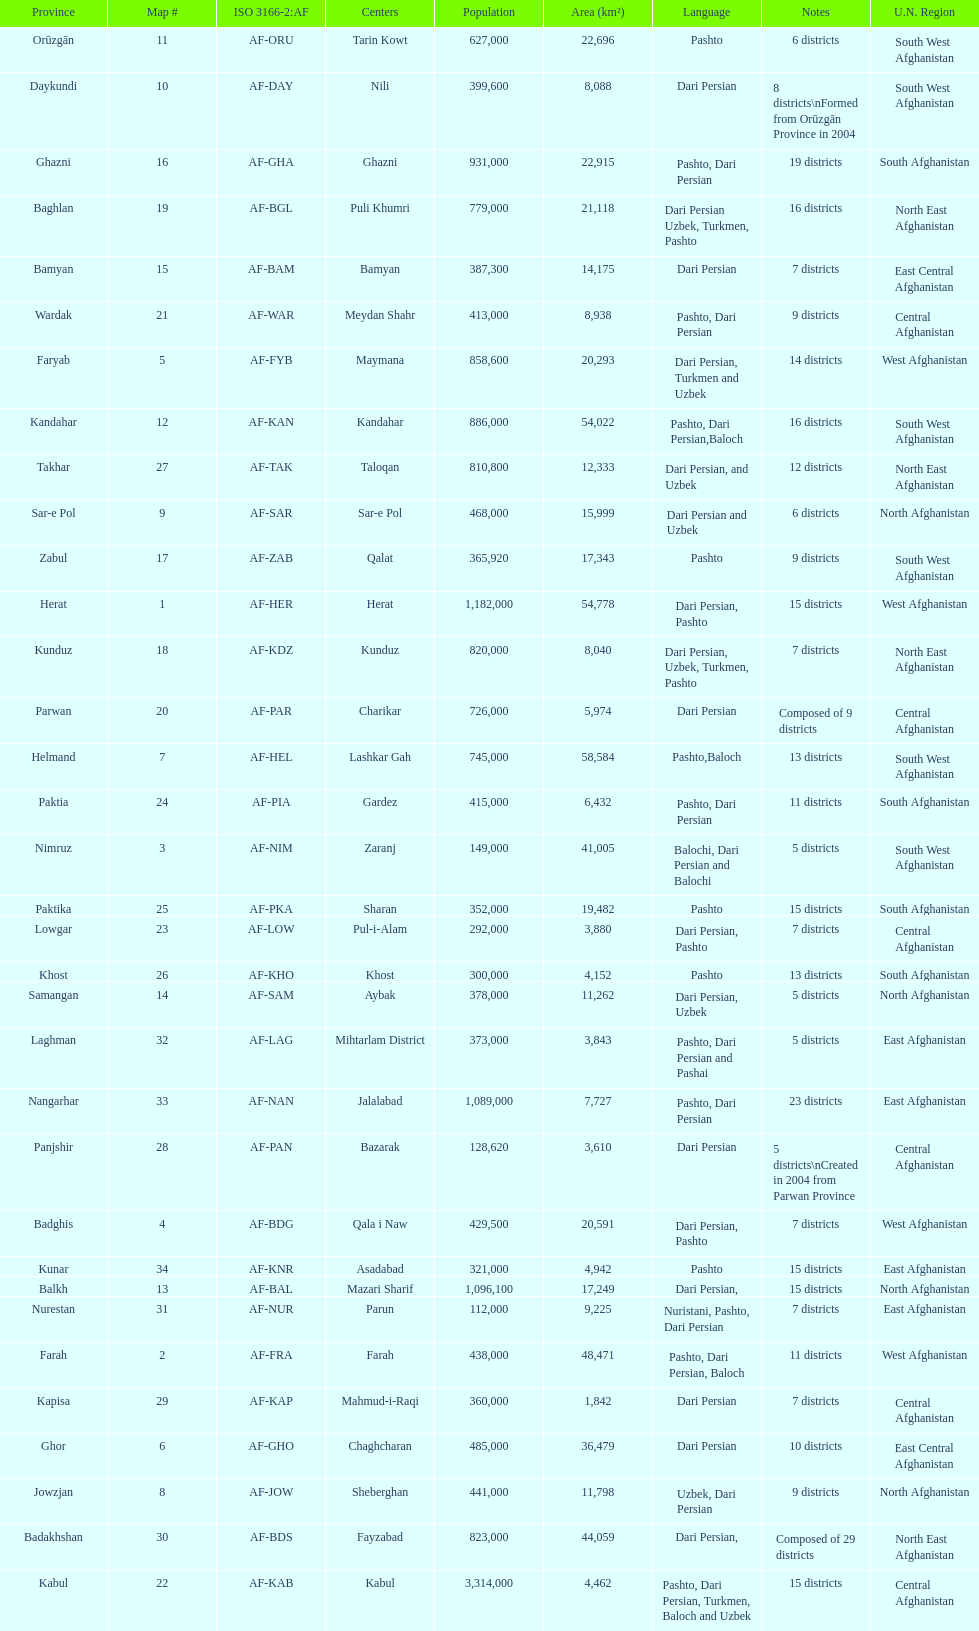What province is listed previous to ghor? Ghazni. Can you parse all the data within this table? {'header': ['Province', 'Map #', 'ISO 3166-2:AF', 'Centers', 'Population', 'Area (km²)', 'Language', 'Notes', 'U.N. Region'], 'rows': [['Orūzgān', '11', 'AF-ORU', 'Tarin Kowt', '627,000', '22,696', 'Pashto', '6 districts', 'South West Afghanistan'], ['Daykundi', '10', 'AF-DAY', 'Nili', '399,600', '8,088', 'Dari Persian', '8 districts\\nFormed from Orūzgān Province in 2004', 'South West Afghanistan'], ['Ghazni', '16', 'AF-GHA', 'Ghazni', '931,000', '22,915', 'Pashto, Dari Persian', '19 districts', 'South Afghanistan'], ['Baghlan', '19', 'AF-BGL', 'Puli Khumri', '779,000', '21,118', 'Dari Persian Uzbek, Turkmen, Pashto', '16 districts', 'North East Afghanistan'], ['Bamyan', '15', 'AF-BAM', 'Bamyan', '387,300', '14,175', 'Dari Persian', '7 districts', 'East Central Afghanistan'], ['Wardak', '21', 'AF-WAR', 'Meydan Shahr', '413,000', '8,938', 'Pashto, Dari Persian', '9 districts', 'Central Afghanistan'], ['Faryab', '5', 'AF-FYB', 'Maymana', '858,600', '20,293', 'Dari Persian, Turkmen and Uzbek', '14 districts', 'West Afghanistan'], ['Kandahar', '12', 'AF-KAN', 'Kandahar', '886,000', '54,022', 'Pashto, Dari Persian,Baloch', '16 districts', 'South West Afghanistan'], ['Takhar', '27', 'AF-TAK', 'Taloqan', '810,800', '12,333', 'Dari Persian, and Uzbek', '12 districts', 'North East Afghanistan'], ['Sar-e Pol', '9', 'AF-SAR', 'Sar-e Pol', '468,000', '15,999', 'Dari Persian and Uzbek', '6 districts', 'North Afghanistan'], ['Zabul', '17', 'AF-ZAB', 'Qalat', '365,920', '17,343', 'Pashto', '9 districts', 'South West Afghanistan'], ['Herat', '1', 'AF-HER', 'Herat', '1,182,000', '54,778', 'Dari Persian, Pashto', '15 districts', 'West Afghanistan'], ['Kunduz', '18', 'AF-KDZ', 'Kunduz', '820,000', '8,040', 'Dari Persian, Uzbek, Turkmen, Pashto', '7 districts', 'North East Afghanistan'], ['Parwan', '20', 'AF-PAR', 'Charikar', '726,000', '5,974', 'Dari Persian', 'Composed of 9 districts', 'Central Afghanistan'], ['Helmand', '7', 'AF-HEL', 'Lashkar Gah', '745,000', '58,584', 'Pashto,Baloch', '13 districts', 'South West Afghanistan'], ['Paktia', '24', 'AF-PIA', 'Gardez', '415,000', '6,432', 'Pashto, Dari Persian', '11 districts', 'South Afghanistan'], ['Nimruz', '3', 'AF-NIM', 'Zaranj', '149,000', '41,005', 'Balochi, Dari Persian and Balochi', '5 districts', 'South West Afghanistan'], ['Paktika', '25', 'AF-PKA', 'Sharan', '352,000', '19,482', 'Pashto', '15 districts', 'South Afghanistan'], ['Lowgar', '23', 'AF-LOW', 'Pul-i-Alam', '292,000', '3,880', 'Dari Persian, Pashto', '7 districts', 'Central Afghanistan'], ['Khost', '26', 'AF-KHO', 'Khost', '300,000', '4,152', 'Pashto', '13 districts', 'South Afghanistan'], ['Samangan', '14', 'AF-SAM', 'Aybak', '378,000', '11,262', 'Dari Persian, Uzbek', '5 districts', 'North Afghanistan'], ['Laghman', '32', 'AF-LAG', 'Mihtarlam District', '373,000', '3,843', 'Pashto, Dari Persian and Pashai', '5 districts', 'East Afghanistan'], ['Nangarhar', '33', 'AF-NAN', 'Jalalabad', '1,089,000', '7,727', 'Pashto, Dari Persian', '23 districts', 'East Afghanistan'], ['Panjshir', '28', 'AF-PAN', 'Bazarak', '128,620', '3,610', 'Dari Persian', '5 districts\\nCreated in 2004 from Parwan Province', 'Central Afghanistan'], ['Badghis', '4', 'AF-BDG', 'Qala i Naw', '429,500', '20,591', 'Dari Persian, Pashto', '7 districts', 'West Afghanistan'], ['Kunar', '34', 'AF-KNR', 'Asadabad', '321,000', '4,942', 'Pashto', '15 districts', 'East Afghanistan'], ['Balkh', '13', 'AF-BAL', 'Mazari Sharif', '1,096,100', '17,249', 'Dari Persian,', '15 districts', 'North Afghanistan'], ['Nurestan', '31', 'AF-NUR', 'Parun', '112,000', '9,225', 'Nuristani, Pashto, Dari Persian', '7 districts', 'East Afghanistan'], ['Farah', '2', 'AF-FRA', 'Farah', '438,000', '48,471', 'Pashto, Dari Persian, Baloch', '11 districts', 'West Afghanistan'], ['Kapisa', '29', 'AF-KAP', 'Mahmud-i-Raqi', '360,000', '1,842', 'Dari Persian', '7 districts', 'Central Afghanistan'], ['Ghor', '6', 'AF-GHO', 'Chaghcharan', '485,000', '36,479', 'Dari Persian', '10 districts', 'East Central Afghanistan'], ['Jowzjan', '8', 'AF-JOW', 'Sheberghan', '441,000', '11,798', 'Uzbek, Dari Persian', '9 districts', 'North Afghanistan'], ['Badakhshan', '30', 'AF-BDS', 'Fayzabad', '823,000', '44,059', 'Dari Persian,', 'Composed of 29 districts', 'North East Afghanistan'], ['Kabul', '22', 'AF-KAB', 'Kabul', '3,314,000', '4,462', 'Pashto, Dari Persian, Turkmen, Baloch and Uzbek', '15 districts', 'Central Afghanistan']]} 